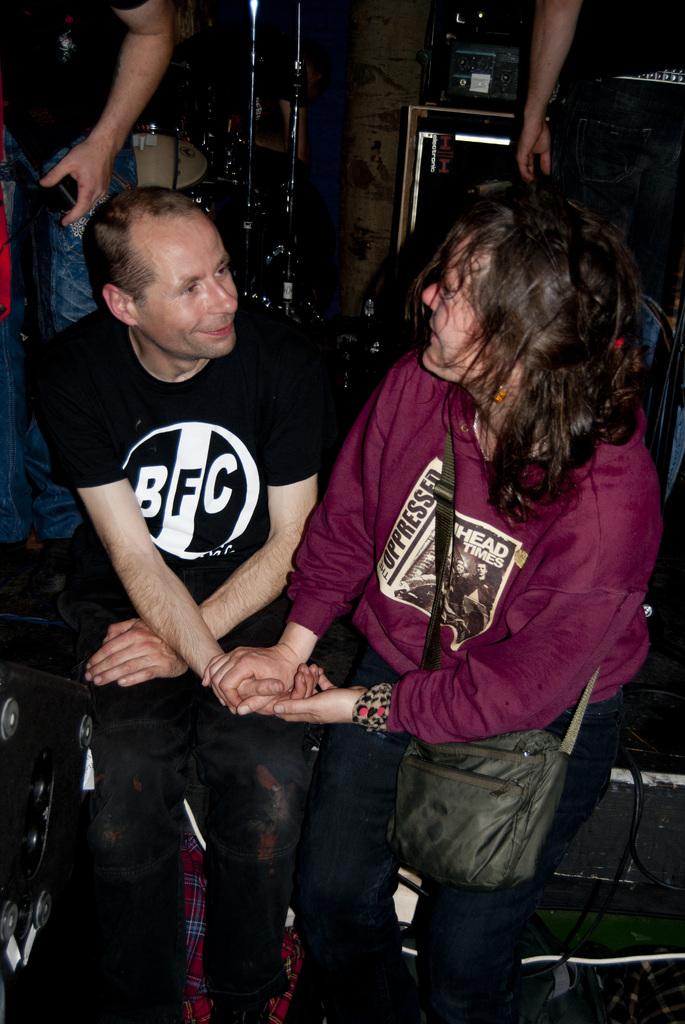What is the acronym on his shirt for?
Your response must be concise. Bfc. What does the text on her shirt say?
Provide a short and direct response. The oppressed. 